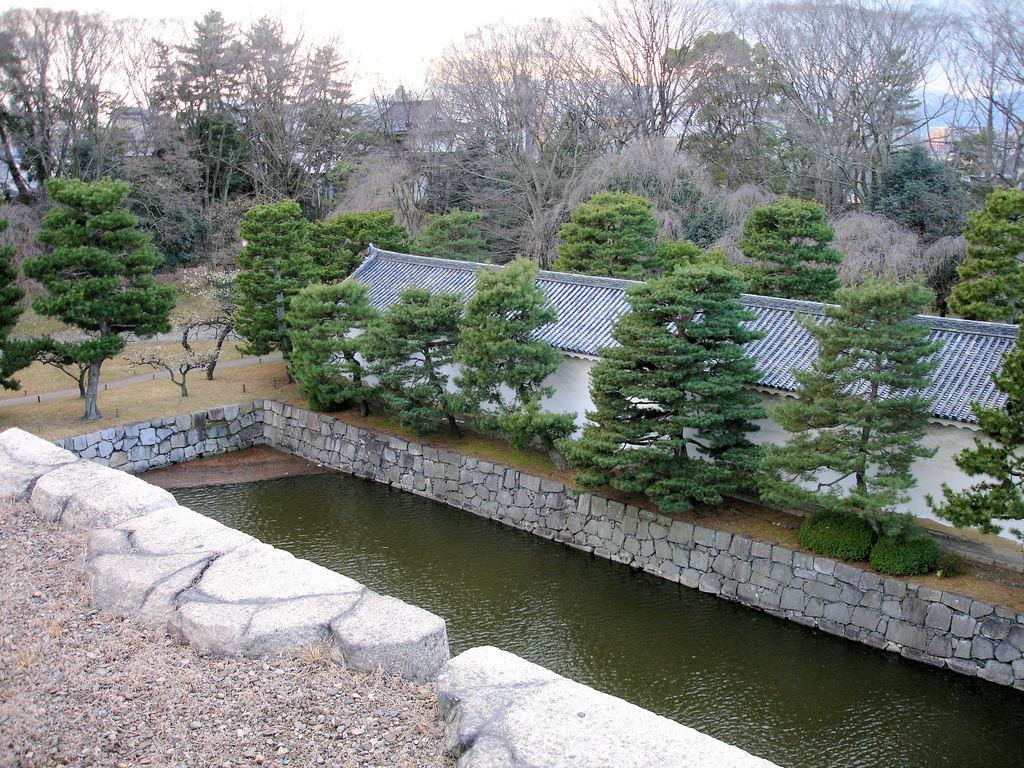Can you describe this image briefly? In this image, we can see some water. There are a few trees, plants and some grass. We can see a shed and the ground with some objects. We can see the wall and some hills. We can see the sky. 